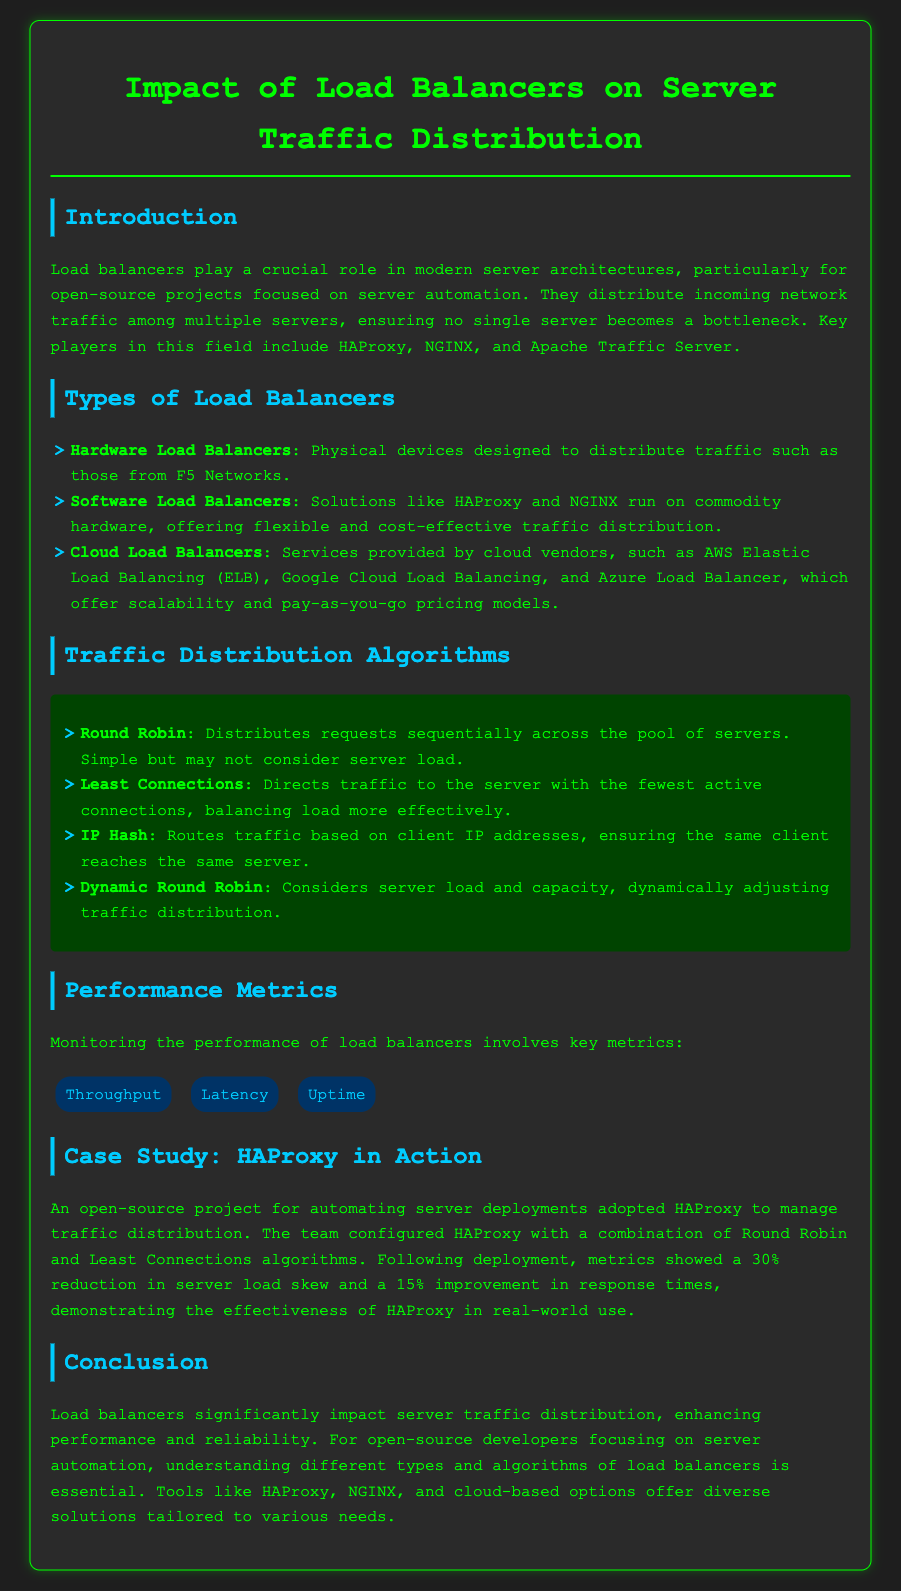What are the key players in load balancing? The key players in load balancing mentioned in the document include HAProxy, NGINX, and Apache Traffic Server.
Answer: HAProxy, NGINX, Apache Traffic Server What is the algorithm that directs traffic to the server with the fewest active connections? The algorithm that directs traffic to the server with the fewest active connections is mentioned as Least Connections.
Answer: Least Connections What percentage reduction in server load skew was achieved with HAProxy? The document states that HAProxy achieved a 30% reduction in server load skew after deployment.
Answer: 30% Which type of load balancer is provided by cloud vendors? The type of load balancer provided by cloud vendors is referred to as Cloud Load Balancers.
Answer: Cloud Load Balancers What is a performance metric mentioned in the report? The report lists Throughput as one of the performance metrics to monitor for load balancers.
Answer: Throughput What does the IP Hash algorithm ensure? The IP Hash algorithm ensures that the same client reaches the same server based on client IP addresses.
Answer: Same client reaches the same server What combination of algorithms did the team configure for HAProxy? The team configured HAProxy with a combination of Round Robin and Least Connections algorithms.
Answer: Round Robin and Least Connections What is the main benefit of using load balancers according to the conclusion? The main benefit is enhancing performance and reliability of server traffic distribution.
Answer: Enhancing performance and reliability 